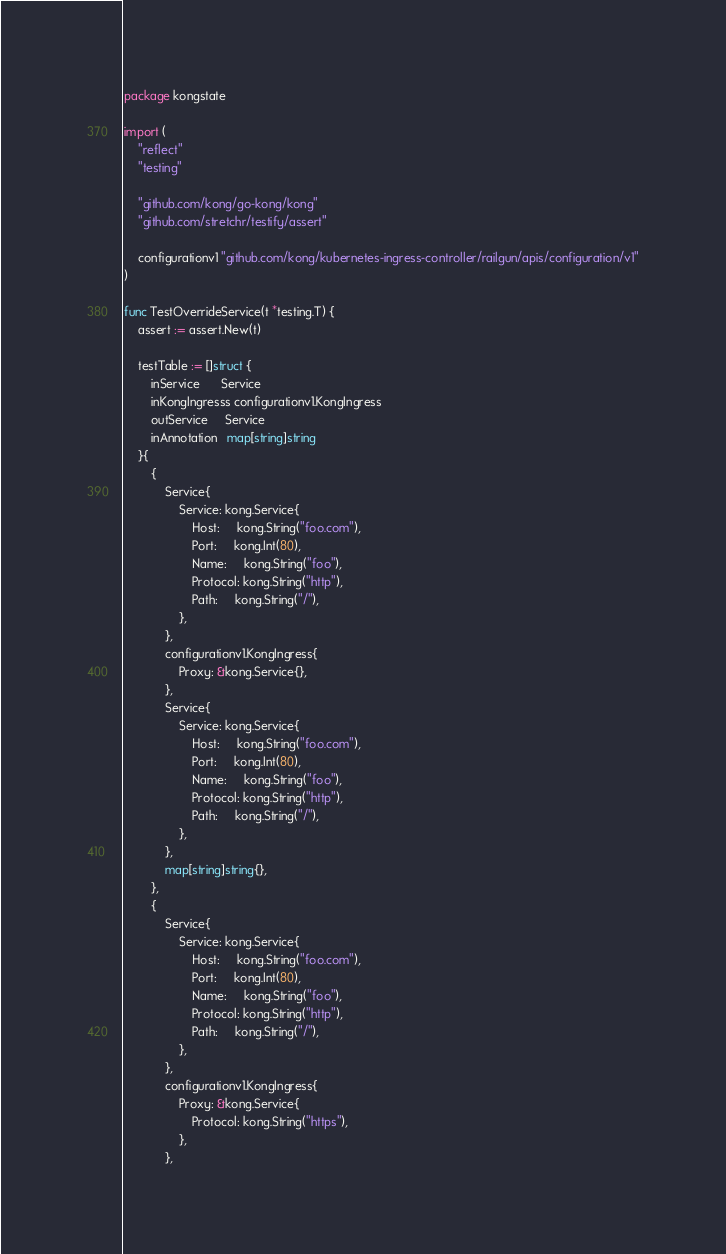<code> <loc_0><loc_0><loc_500><loc_500><_Go_>package kongstate

import (
	"reflect"
	"testing"

	"github.com/kong/go-kong/kong"
	"github.com/stretchr/testify/assert"

	configurationv1 "github.com/kong/kubernetes-ingress-controller/railgun/apis/configuration/v1"
)

func TestOverrideService(t *testing.T) {
	assert := assert.New(t)

	testTable := []struct {
		inService      Service
		inKongIngresss configurationv1.KongIngress
		outService     Service
		inAnnotation   map[string]string
	}{
		{
			Service{
				Service: kong.Service{
					Host:     kong.String("foo.com"),
					Port:     kong.Int(80),
					Name:     kong.String("foo"),
					Protocol: kong.String("http"),
					Path:     kong.String("/"),
				},
			},
			configurationv1.KongIngress{
				Proxy: &kong.Service{},
			},
			Service{
				Service: kong.Service{
					Host:     kong.String("foo.com"),
					Port:     kong.Int(80),
					Name:     kong.String("foo"),
					Protocol: kong.String("http"),
					Path:     kong.String("/"),
				},
			},
			map[string]string{},
		},
		{
			Service{
				Service: kong.Service{
					Host:     kong.String("foo.com"),
					Port:     kong.Int(80),
					Name:     kong.String("foo"),
					Protocol: kong.String("http"),
					Path:     kong.String("/"),
				},
			},
			configurationv1.KongIngress{
				Proxy: &kong.Service{
					Protocol: kong.String("https"),
				},
			},</code> 